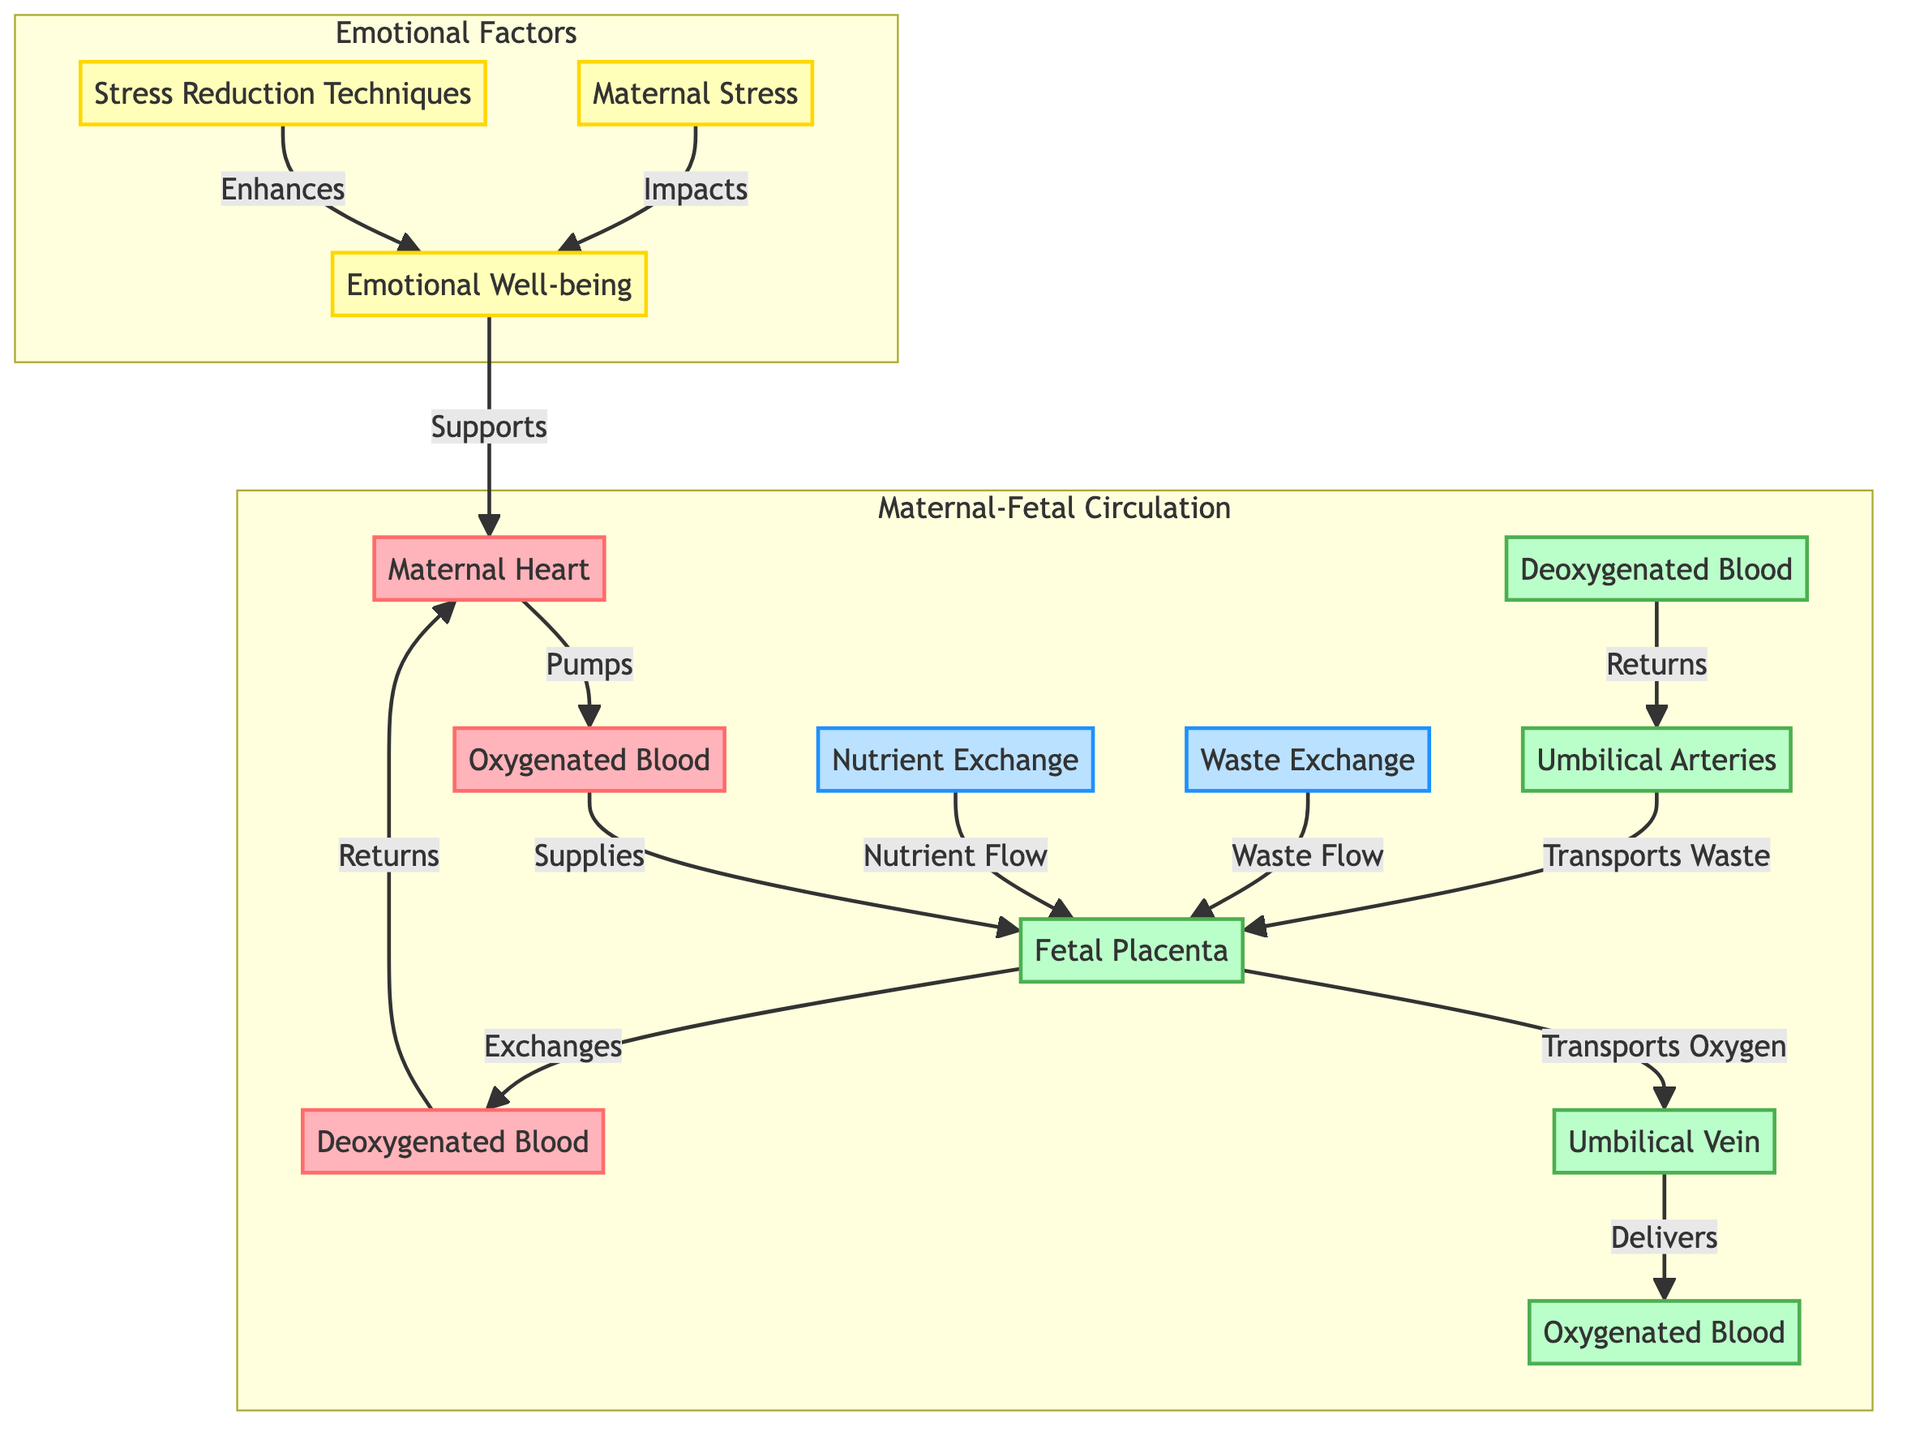What is pumped by the maternal heart? The diagram indicates that the maternal heart pumps oxygenated blood. This is the first step shown in the flow from the maternal heart to the placenta.
Answer: Oxygenated Blood Which arteries transport waste from the fetus? The diagram shows that the umbilical arteries transport waste from the fetus back to the placenta. This is noted in the flow from fetal deoxygenated blood to the umbilical arteries.
Answer: Umbilical Arteries How many main components are involved in the maternal-fetal circulation? By counting the nodes in the "Maternal-Fetal Circulation" subgraph, we see there are eight elements, including maternal heart, placenta, umbilical vein, umbilical arteries, and various blood types.
Answer: Eight What impact does maternal stress have? According to the diagram, maternal stress impacts emotional wellbeing, indicating a direct relationship is drawn. This is evaluated from the connection between maternal stress and emotional wellbeing.
Answer: Impacts What enhances emotional wellbeing? The diagram specifies that stress reduction techniques enhance emotional wellbeing. This relationship is noted with an arrow pointing from stress reduction to emotional wellbeing.
Answer: Stress Reduction Techniques What flows from the fetal placenta to the maternal deoxygenated blood? In the diagram, the fetal placenta exchanges substances with the maternal deoxygenated blood. This connection indicates a reciprocal flow regarding nutrient and gas exchange.
Answer: Exchanges Explain the correlation between maternal stress and maternal heart function. Maternal stress adversely affects emotional wellbeing, and emotional wellbeing supports the maternal heart. Therefore, increased maternal stress can ultimately lead to less effective maternal heart functioning due to decreased emotional wellbeing. This involves tracing from maternal stress to emotional wellbeing and then to the maternal heart.
Answer: Adversely affects How are nutrients exchanged between mother and fetus? The diagram illustrates that nutrient exchange occurs at the fetal placenta, where nutrients flow into the fetal circulation and deoxygenated blood returns to the mother. This exchange mechanism is explicitly defined as occurring between fetal and maternal circulation through the placenta.
Answer: Nutrient Exchange What connects the umbilical vein and fetal oxygenated blood? The diagram indicates that the umbilical vein delivers oxygen to the fetal oxygenated blood. The flow illustrates that oxygen moves from the placenta through the umbilical vein into the fetal bloodstream.
Answer: Delivers 